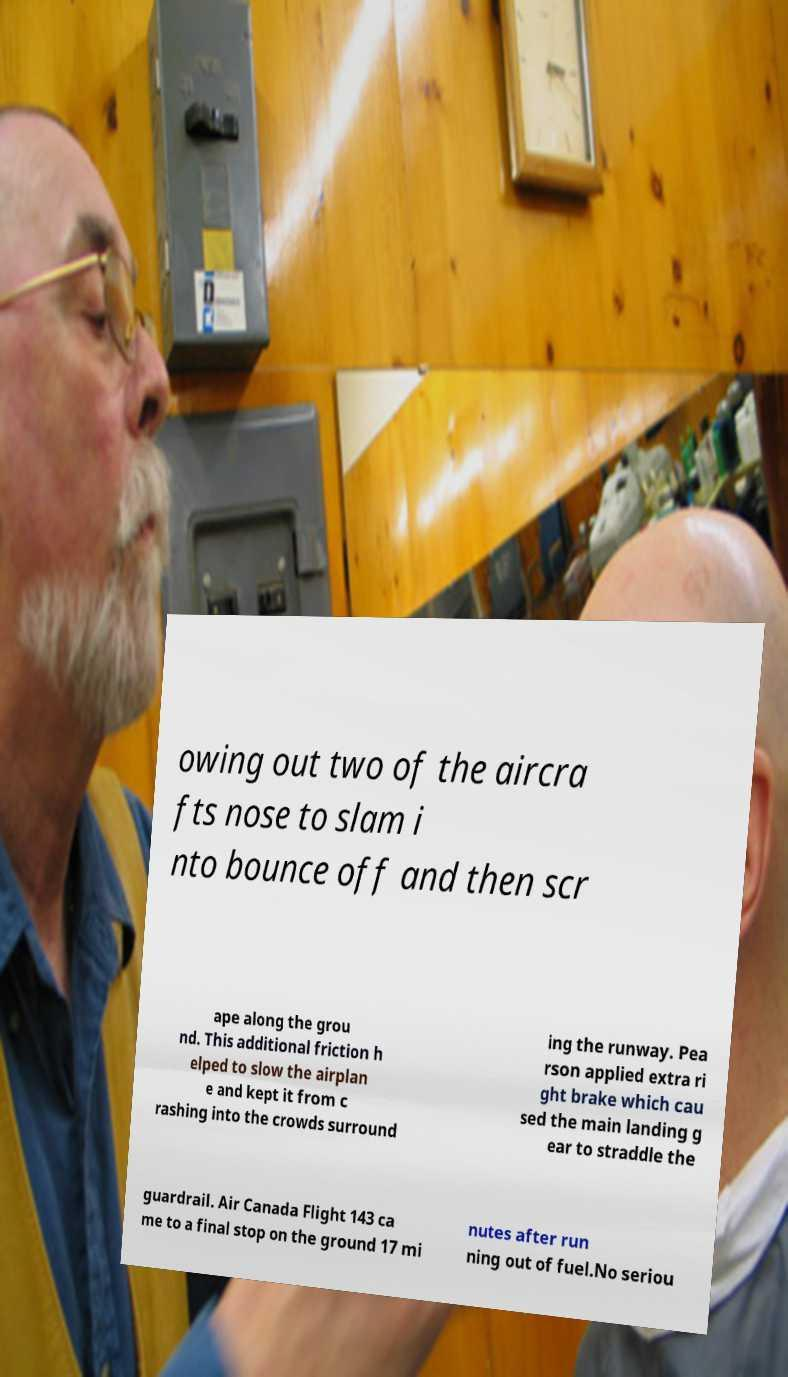For documentation purposes, I need the text within this image transcribed. Could you provide that? owing out two of the aircra fts nose to slam i nto bounce off and then scr ape along the grou nd. This additional friction h elped to slow the airplan e and kept it from c rashing into the crowds surround ing the runway. Pea rson applied extra ri ght brake which cau sed the main landing g ear to straddle the guardrail. Air Canada Flight 143 ca me to a final stop on the ground 17 mi nutes after run ning out of fuel.No seriou 